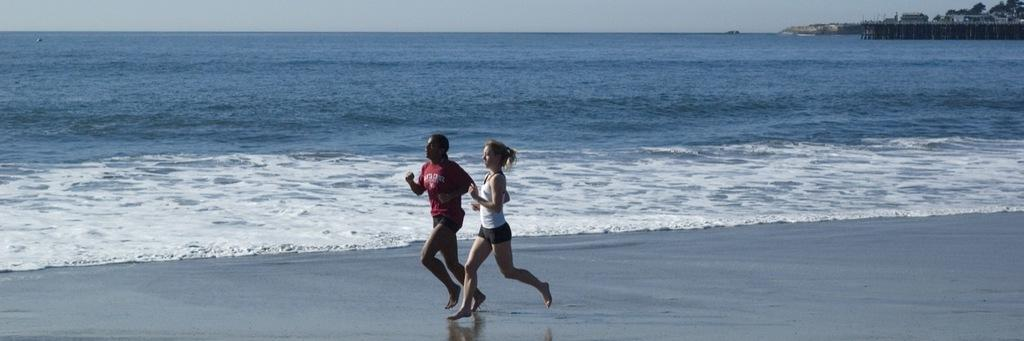How many women are in the image? There are two women in the image. What are the women doing in the image? The women are running in the beach. What can be seen on the right side of the image? There are buildings, trees, and a fence on the right side of the image. What is visible in the sky in the image? The sky is visible in the image. What scent can be detected from the women's wrists in the image? There is no information about scents or wrists in the image, as it focuses on the women running in the beach and the surrounding environment. 